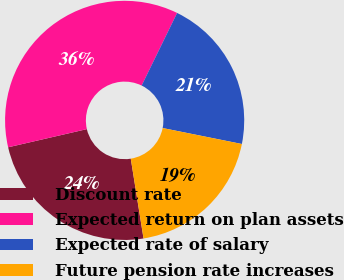<chart> <loc_0><loc_0><loc_500><loc_500><pie_chart><fcel>Discount rate<fcel>Expected return on plan assets<fcel>Expected rate of salary<fcel>Future pension rate increases<nl><fcel>23.91%<fcel>35.84%<fcel>20.93%<fcel>19.31%<nl></chart> 